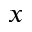Convert formula to latex. <formula><loc_0><loc_0><loc_500><loc_500>x</formula> 